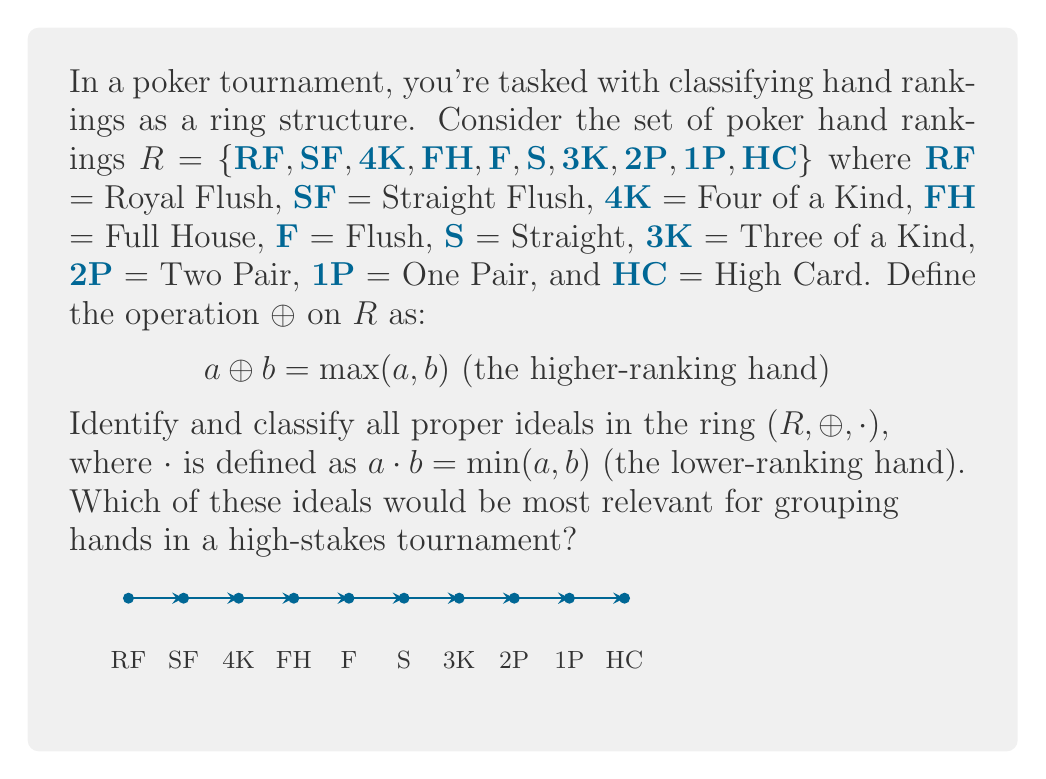Teach me how to tackle this problem. To identify and classify the ideals in this ring, we need to follow these steps:

1) First, recall that for a ring $(R, \oplus, \cdot)$, a subset $I$ of $R$ is an ideal if:
   a) $(I, \oplus)$ is a subgroup of $(R, \oplus)$
   b) For all $r \in R$ and $i \in I$, both $r \cdot i \in I$ and $i \cdot r \in I$

2) In our case, $\oplus$ is $\max$ and $\cdot$ is $\min$. This means that for any subset to be an ideal, it must be closed under taking the maximum and minimum with any element in $R$.

3) Let's start from the "bottom" of our ranking. The set $\{HC\}$ is closed under both operations with any element in $R$, so it's an ideal.

4) Similarly, $\{HC, 1P\}$, $\{HC, 1P, 2P\}$, and so on, up to $R$ itself, are all ideals.

5) Therefore, the proper ideals of $R$ are:
   $I_1 = \{HC\}$
   $I_2 = \{HC, 1P\}$
   $I_3 = \{HC, 1P, 2P\}$
   $I_4 = \{HC, 1P, 2P, 3K\}$
   $I_5 = \{HC, 1P, 2P, 3K, S\}$
   $I_6 = \{HC, 1P, 2P, 3K, S, F\}$
   $I_7 = \{HC, 1P, 2P, 3K, S, F, FH\}$
   $I_8 = \{HC, 1P, 2P, 3K, S, F, FH, 4K\}$
   $I_9 = \{HC, 1P, 2P, 3K, S, F, FH, 4K, SF\}$

6) These ideals form a chain: $I_1 \subset I_2 \subset I_3 \subset ... \subset I_9 \subset R$

7) For a high-stakes tournament, the most relevant ideal would likely be $I_6$ or $I_7$. $I_6$ includes all hands up to and including Flush, which are more common hands that most players might achieve. $I_7$ includes Full House, which is often considered the threshold for a very strong hand in high-stakes games.
Answer: The proper ideals are $I_k = \{HC, 1P, ..., \text{k-th ranking}\}$ for $k=1$ to $9$. $I_6$ or $I_7$ is most relevant for high-stakes tournaments. 